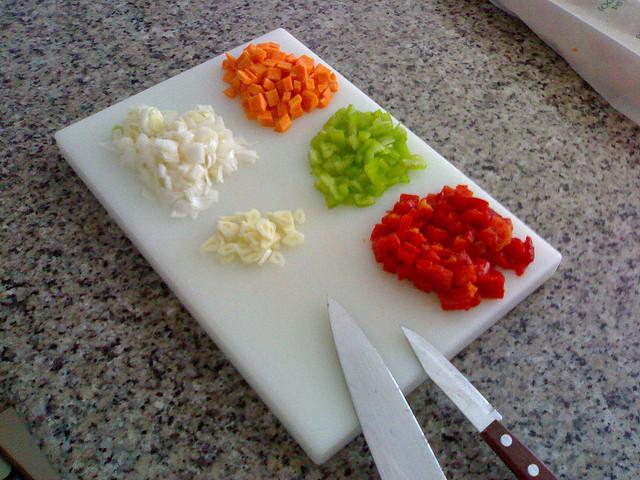Is there one knife or two?
Write a very short answer. 2. Is there any fruit on the cutting board?
Keep it brief. No. What color is the cutting board?
Write a very short answer. White. What color is the vegetable in this dish?
Answer briefly. Orange. What color are the veggies?
Answer briefly. White, yellow, orange, green, red. 